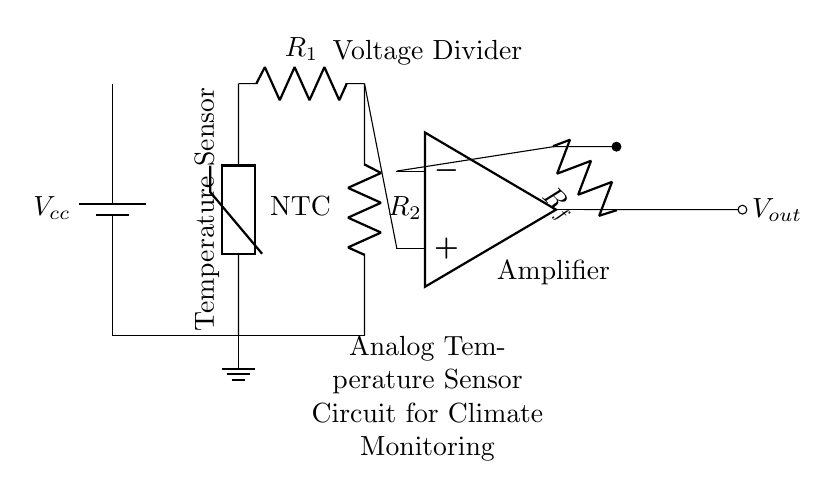What type of temperature sensor is used in the circuit? The circuit diagram shows an NTC thermistor as the temperature sensor, which is indicated by the symbol with the label "NTC". NTC stands for Negative Temperature Coefficient, meaning its resistance decreases as temperature increases.
Answer: NTC thermistor What is the purpose of the resistor R1 in the voltage divider? Resistor R1 is part of the voltage divider and helps in setting the appropriate voltage level for the Op-amp. It divides the voltage provided by the battery to create a measurable output voltage related to the temperature detected by the thermistor.
Answer: Voltage divider How does the Op-amp function in this circuit? The Op-amp amplifies the difference between its inputs. In this circuit, it receives the voltage from the voltage divider formed by the thermistor and resistor R1, amplifying the signal to create a proportional output voltage representing the temperature.
Answer: Amplifier What is the output node labeled in the circuit? The output node is labeled Vout, indicating the voltage output from the Op-amp after it has amplified the signal from the voltage divider configuration. This output represents the temperature measurement processed by the circuit.
Answer: Vout What happens to the output voltage when the temperature increases? When the temperature increases, the resistance of the NTC thermistor decreases, leading to a change in the voltage at the Op-amp input. This causes the output voltage Vout to increase correspondingly, representing higher temperatures.
Answer: Output increases What role does the feedback resistor Rf play in the Op-amp configuration? The feedback resistor Rf determines the gain of the Op-amp circuit. By providing feedback, it allows the Op-amp to adjust its output based on the input signal, thereby stabilizing the amplification and ensuring that it operates within desired limits.
Answer: Gain adjustment How does the circuit connect to ground? The circuit is connected to ground through the bottom connection of the thermistor and also through the series connection at the Resistor R2 that brings the current path down to ground level. This ensures a reference point for voltage measurements.
Answer: Ground connection 